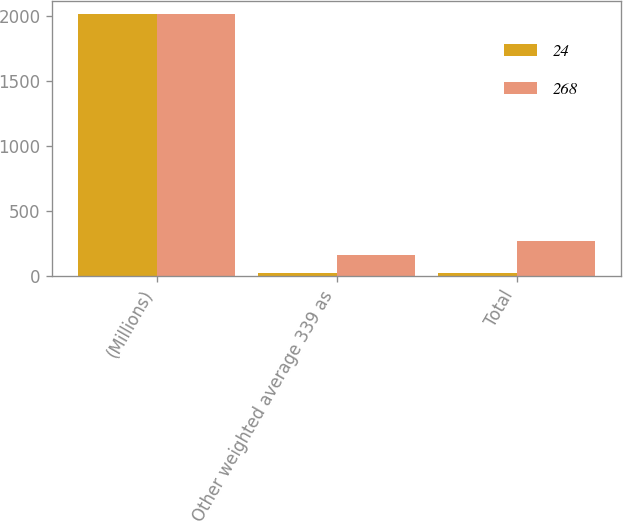Convert chart to OTSL. <chart><loc_0><loc_0><loc_500><loc_500><stacked_bar_chart><ecel><fcel>(Millions)<fcel>Other weighted average 339 as<fcel>Total<nl><fcel>24<fcel>2010<fcel>24<fcel>24<nl><fcel>268<fcel>2009<fcel>158<fcel>268<nl></chart> 